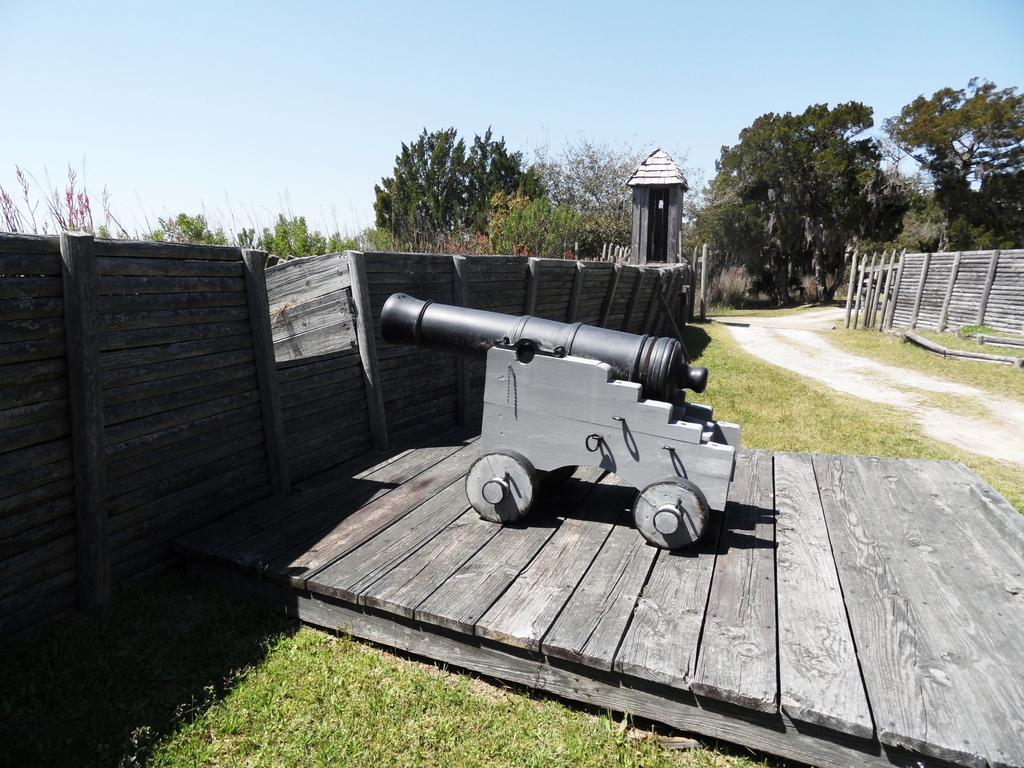What is the main object in the center of the image? There is a cannon in the center of the image. What type of terrain is visible at the bottom of the image? There is grass at the bottom of the image. What can be seen in the distance in the image? There are trees in the background of the image. What type of hook can be seen attached to the cannon in the image? There is no hook attached to the cannon in the image. What type of sand is visible in the image? There is no sand present in the image. 